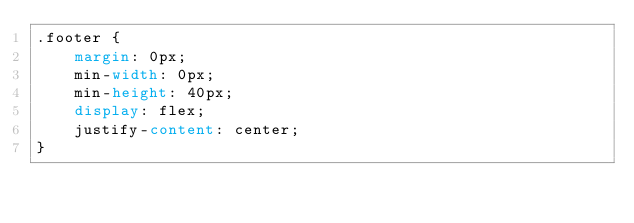Convert code to text. <code><loc_0><loc_0><loc_500><loc_500><_CSS_>.footer {
    margin: 0px;
    min-width: 0px;
    min-height: 40px;
    display: flex;
    justify-content: center;
}</code> 